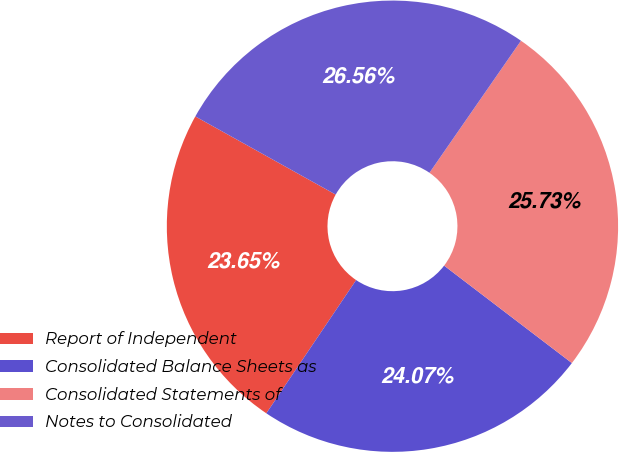Convert chart. <chart><loc_0><loc_0><loc_500><loc_500><pie_chart><fcel>Report of Independent<fcel>Consolidated Balance Sheets as<fcel>Consolidated Statements of<fcel>Notes to Consolidated<nl><fcel>23.65%<fcel>24.07%<fcel>25.73%<fcel>26.56%<nl></chart> 